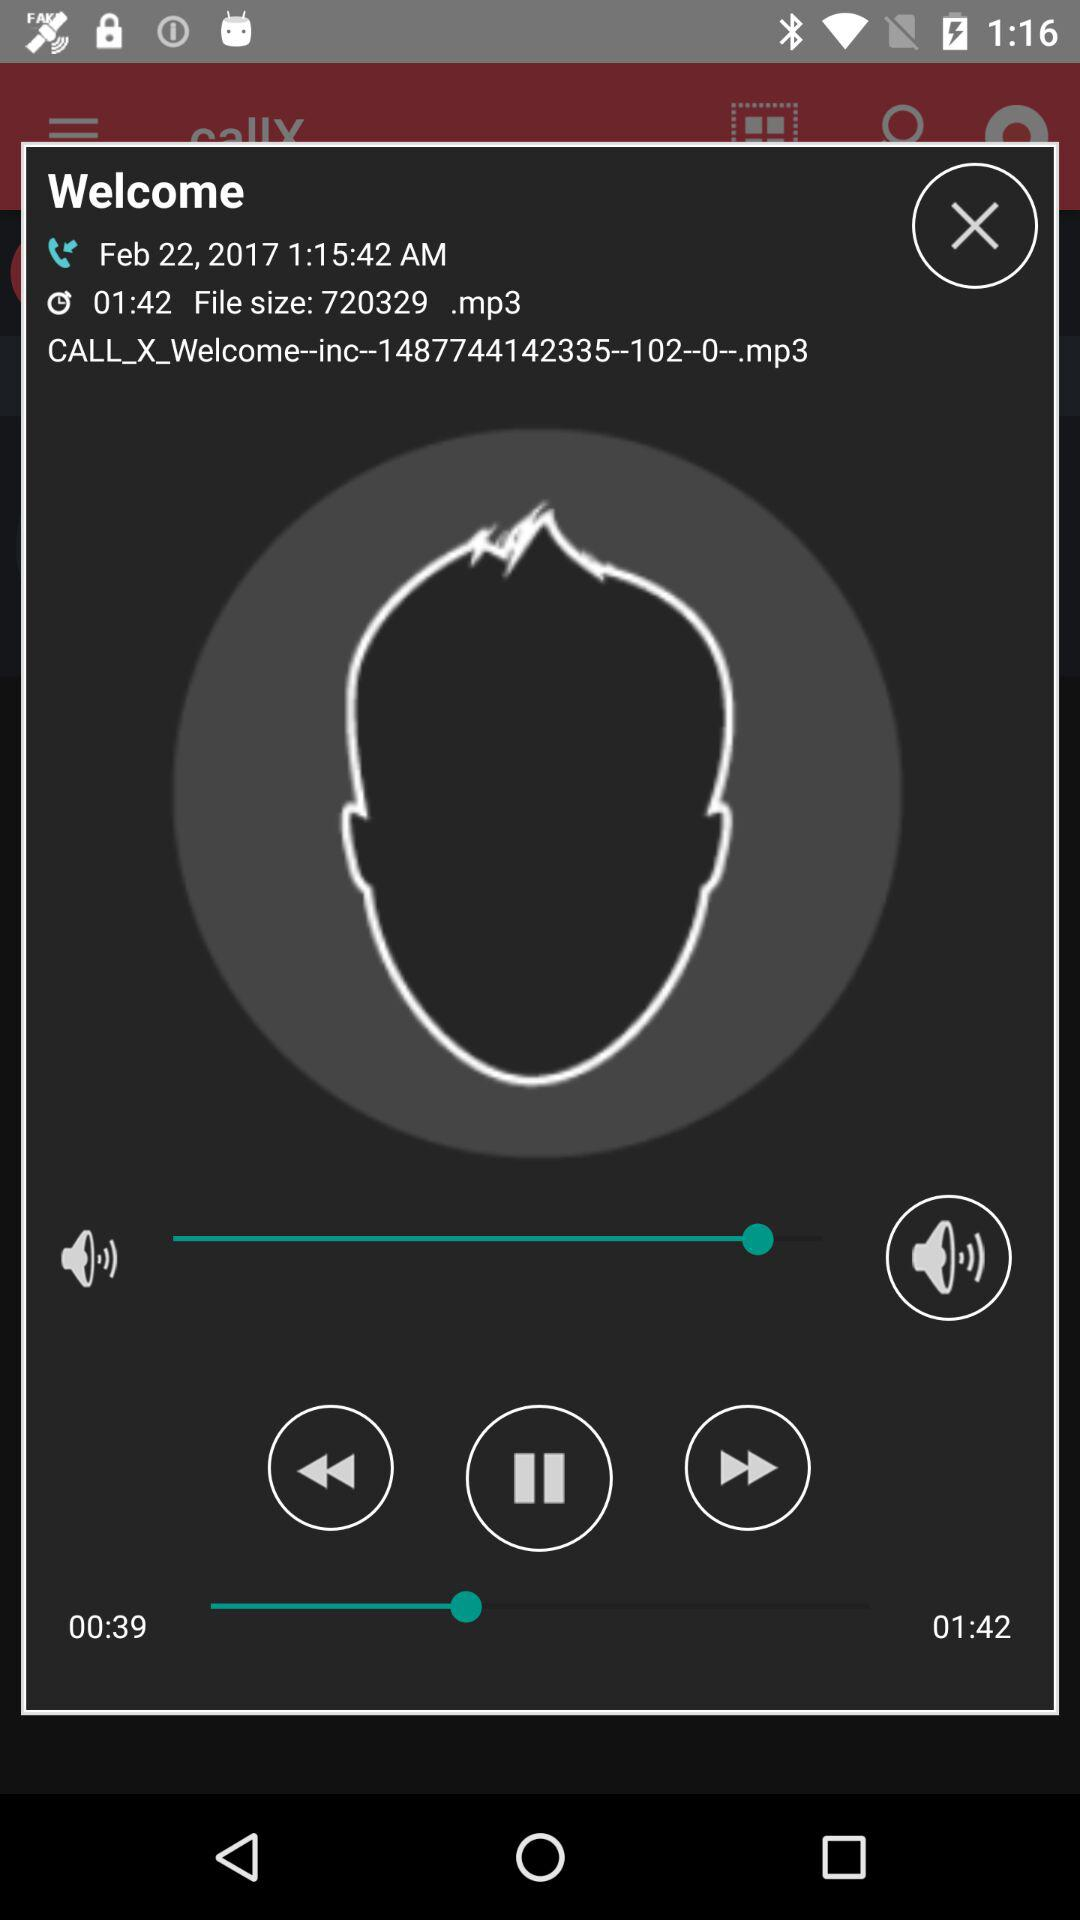What is the file size? The file size is 720329. 